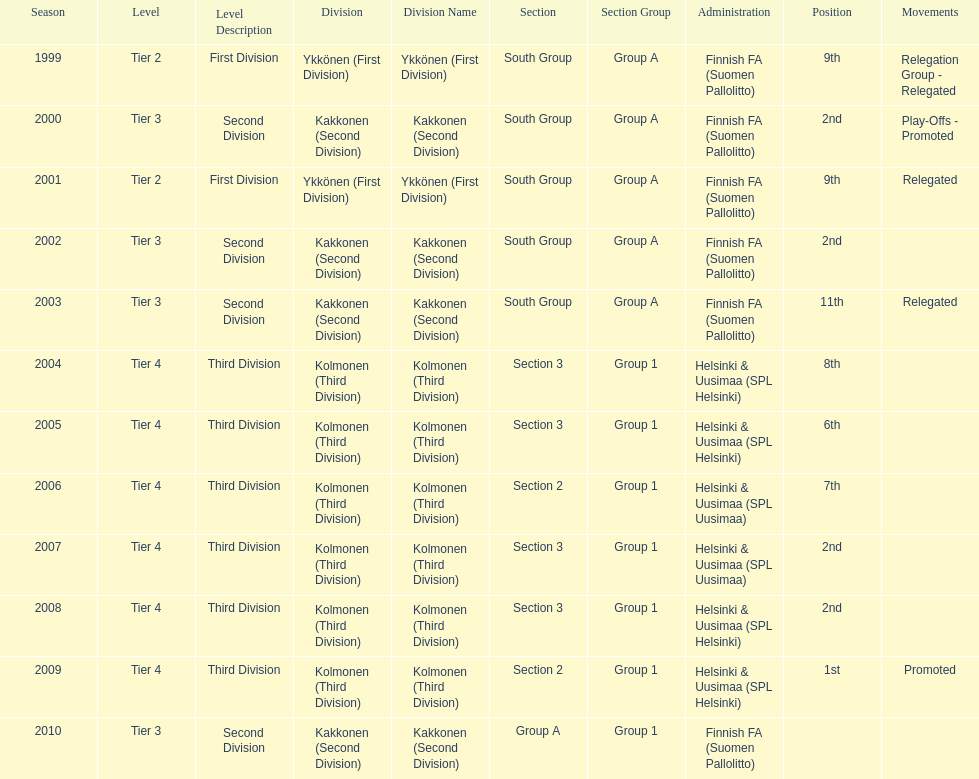When was the last year they placed 2nd? 2008. 